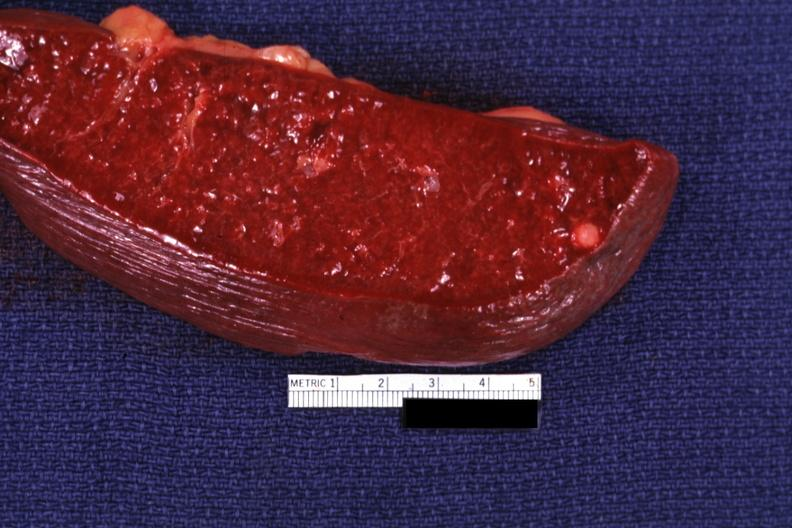what is cut surface with typical healed?
Answer the question using a single word or phrase. Granuloma 